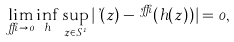Convert formula to latex. <formula><loc_0><loc_0><loc_500><loc_500>\lim _ { \delta \to 0 } \inf _ { h } \sup _ { z \in S ^ { 1 } } | \varphi ( z ) - \varphi ^ { \delta } ( h ( z ) ) | = 0 ,</formula> 